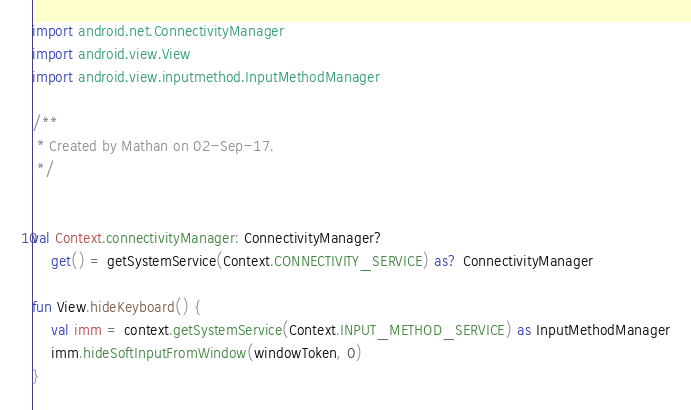Convert code to text. <code><loc_0><loc_0><loc_500><loc_500><_Kotlin_>import android.net.ConnectivityManager
import android.view.View
import android.view.inputmethod.InputMethodManager

/**
 * Created by Mathan on 02-Sep-17.
 */


val Context.connectivityManager: ConnectivityManager?
    get() = getSystemService(Context.CONNECTIVITY_SERVICE) as? ConnectivityManager

fun View.hideKeyboard() {
    val imm = context.getSystemService(Context.INPUT_METHOD_SERVICE) as InputMethodManager
    imm.hideSoftInputFromWindow(windowToken, 0)
}</code> 